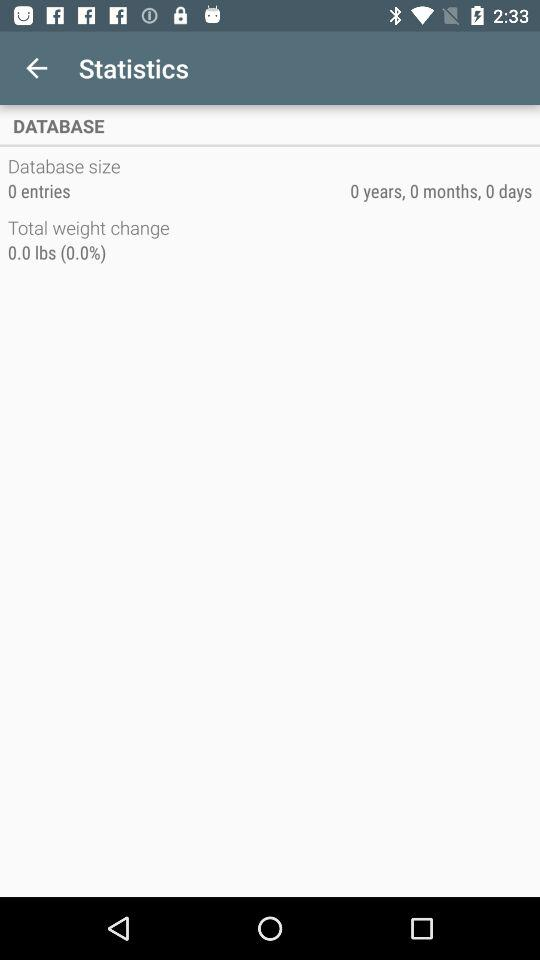How much total weight change has been recorded?
Answer the question using a single word or phrase. 0.0 lbs (0.0%) 